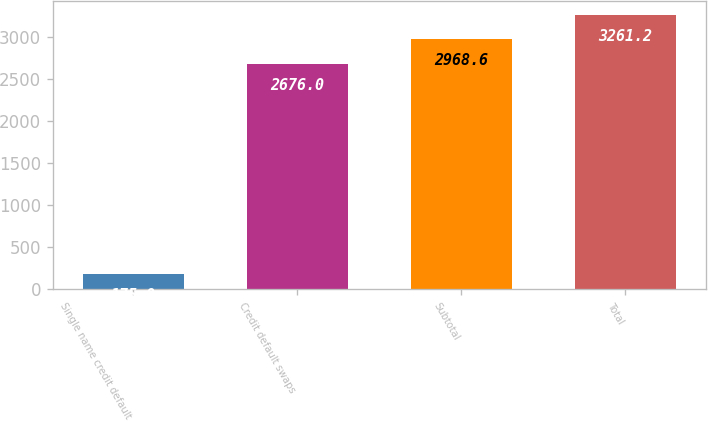<chart> <loc_0><loc_0><loc_500><loc_500><bar_chart><fcel>Single name credit default<fcel>Credit default swaps<fcel>Subtotal<fcel>Total<nl><fcel>175<fcel>2676<fcel>2968.6<fcel>3261.2<nl></chart> 